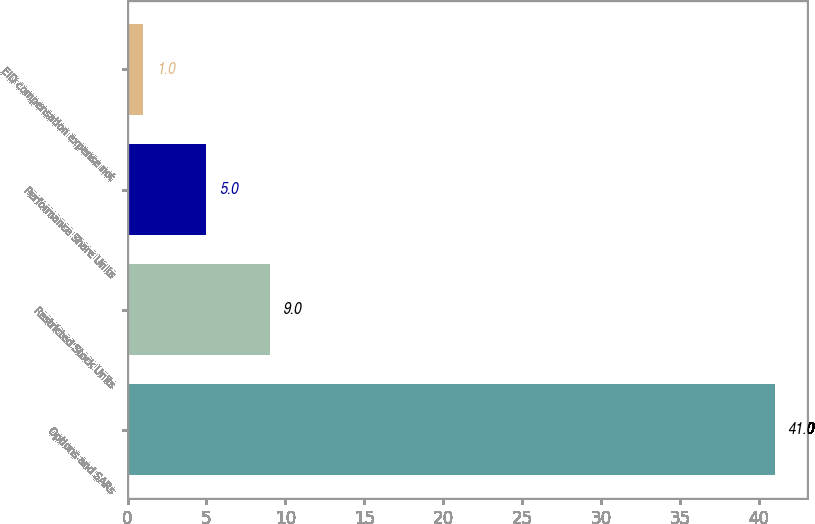Convert chart to OTSL. <chart><loc_0><loc_0><loc_500><loc_500><bar_chart><fcel>Options and SARs<fcel>Restricted Stock Units<fcel>Performance Share Units<fcel>EID compensation expense not<nl><fcel>41<fcel>9<fcel>5<fcel>1<nl></chart> 